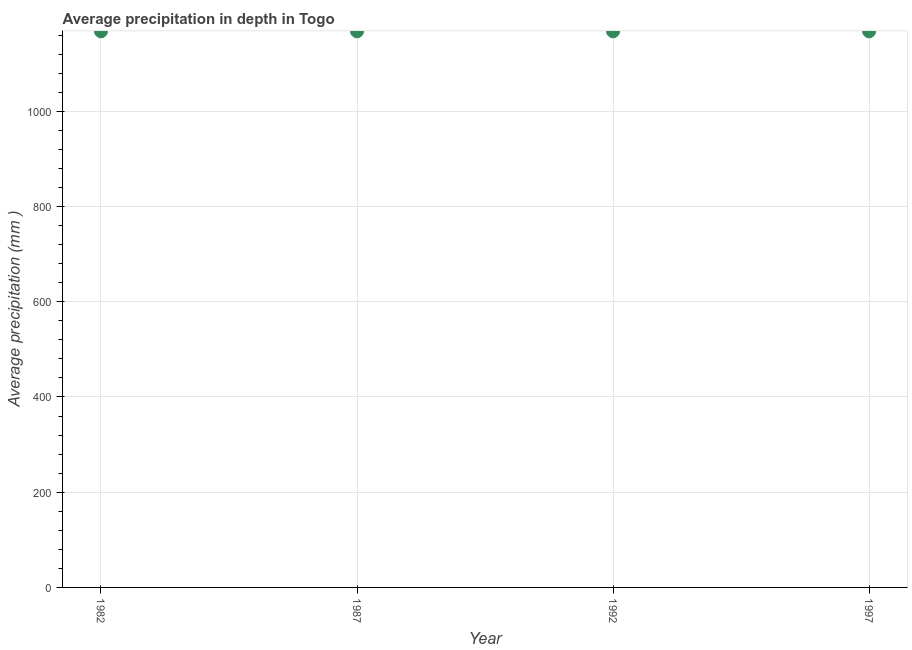What is the average precipitation in depth in 1997?
Offer a terse response. 1168. Across all years, what is the maximum average precipitation in depth?
Give a very brief answer. 1168. Across all years, what is the minimum average precipitation in depth?
Provide a short and direct response. 1168. In which year was the average precipitation in depth maximum?
Offer a terse response. 1982. In which year was the average precipitation in depth minimum?
Offer a very short reply. 1982. What is the sum of the average precipitation in depth?
Your answer should be very brief. 4672. What is the average average precipitation in depth per year?
Give a very brief answer. 1168. What is the median average precipitation in depth?
Provide a succinct answer. 1168. Do a majority of the years between 1987 and 1992 (inclusive) have average precipitation in depth greater than 560 mm?
Ensure brevity in your answer.  Yes. Is the average precipitation in depth in 1987 less than that in 1997?
Your answer should be very brief. No. How many years are there in the graph?
Ensure brevity in your answer.  4. Are the values on the major ticks of Y-axis written in scientific E-notation?
Your response must be concise. No. Does the graph contain grids?
Your response must be concise. Yes. What is the title of the graph?
Ensure brevity in your answer.  Average precipitation in depth in Togo. What is the label or title of the X-axis?
Your response must be concise. Year. What is the label or title of the Y-axis?
Provide a short and direct response. Average precipitation (mm ). What is the Average precipitation (mm ) in 1982?
Make the answer very short. 1168. What is the Average precipitation (mm ) in 1987?
Ensure brevity in your answer.  1168. What is the Average precipitation (mm ) in 1992?
Your answer should be very brief. 1168. What is the Average precipitation (mm ) in 1997?
Provide a short and direct response. 1168. What is the difference between the Average precipitation (mm ) in 1982 and 1997?
Provide a succinct answer. 0. What is the difference between the Average precipitation (mm ) in 1987 and 1992?
Your answer should be compact. 0. What is the difference between the Average precipitation (mm ) in 1987 and 1997?
Offer a very short reply. 0. What is the ratio of the Average precipitation (mm ) in 1982 to that in 1987?
Offer a very short reply. 1. What is the ratio of the Average precipitation (mm ) in 1992 to that in 1997?
Provide a succinct answer. 1. 